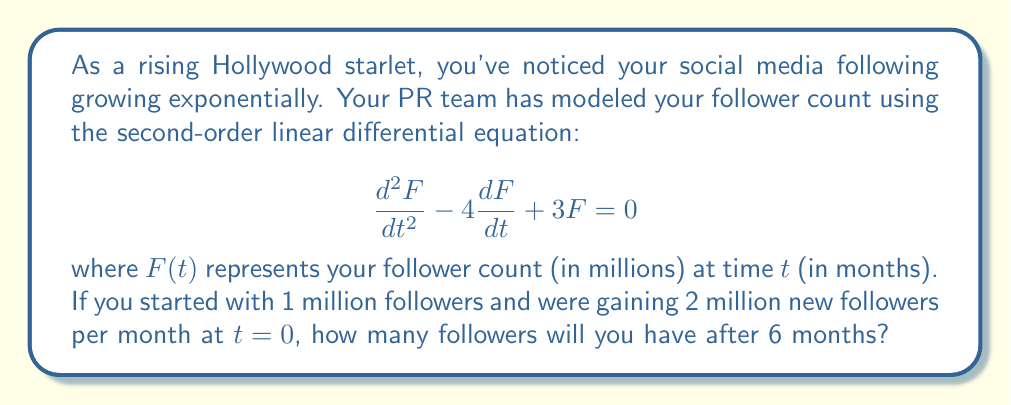Could you help me with this problem? To solve this problem, we need to follow these steps:

1) The general solution to the given second-order linear differential equation is:

   $$F(t) = c_1e^{3t} + c_2e^t$$

2) We need to find $c_1$ and $c_2$ using the initial conditions:
   
   At $t=0$, $F(0) = 1$ (initial follower count in millions)
   At $t=0$, $F'(0) = 2$ (initial rate of follower gain in millions per month)

3) Using the first condition:

   $$F(0) = c_1 + c_2 = 1$$

4) For the second condition, we differentiate $F(t)$:

   $$F'(t) = 3c_1e^{3t} + c_2e^t$$

   Then evaluate at $t=0$:

   $$F'(0) = 3c_1 + c_2 = 2$$

5) Now we have a system of two equations:

   $$c_1 + c_2 = 1$$
   $$3c_1 + c_2 = 2$$

6) Subtracting the first equation from the second:

   $$2c_1 = 1$$
   $$c_1 = \frac{1}{2}$$

7) Substituting this back into the first equation:

   $$\frac{1}{2} + c_2 = 1$$
   $$c_2 = \frac{1}{2}$$

8) Now we have our particular solution:

   $$F(t) = \frac{1}{2}e^{3t} + \frac{1}{2}e^t$$

9) To find the follower count after 6 months, we evaluate $F(6)$:

   $$F(6) = \frac{1}{2}e^{18} + \frac{1}{2}e^6$$

10) Using a calculator to evaluate this expression:

    $$F(6) \approx 33.19 \text{ million followers}$$
Answer: After 6 months, you will have approximately 33.19 million followers. 